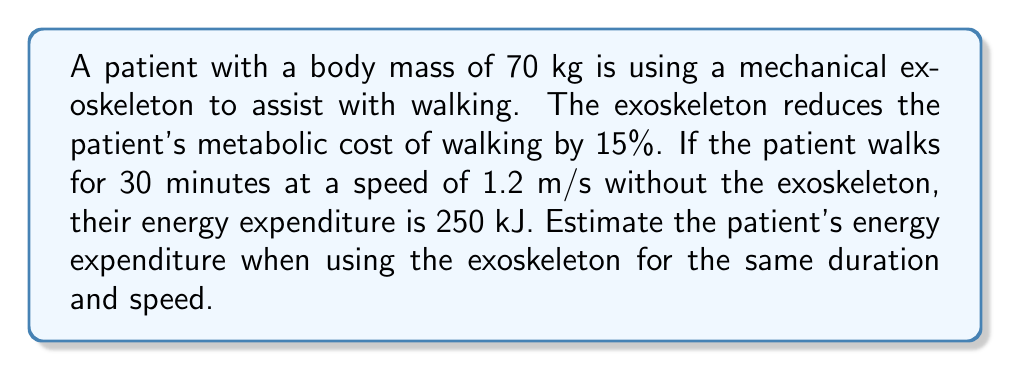Help me with this question. To solve this problem, we'll follow these steps:

1. Calculate the energy expenditure rate without the exoskeleton:
   $$\text{Rate} = \frac{\text{Energy}}{\text{Time}} = \frac{250 \text{ kJ}}{30 \text{ min}} = 8.33 \text{ kJ/min}$$

2. Convert the rate to kJ/s:
   $$8.33 \text{ kJ/min} \times \frac{1 \text{ min}}{60 \text{ s}} = 0.139 \text{ kJ/s}$$

3. Calculate the reduced energy expenditure rate with the exoskeleton:
   $$\text{Reduced rate} = 0.139 \text{ kJ/s} \times (1 - 0.15) = 0.118 \text{ kJ/s}$$

4. Calculate the total energy expenditure for 30 minutes with the exoskeleton:
   $$\text{Energy} = 0.118 \text{ kJ/s} \times 30 \text{ min} \times 60 \text{ s/min} = 212.5 \text{ kJ}$$

Therefore, the patient's estimated energy expenditure when using the exoskeleton for 30 minutes at 1.2 m/s is 212.5 kJ.
Answer: 212.5 kJ 